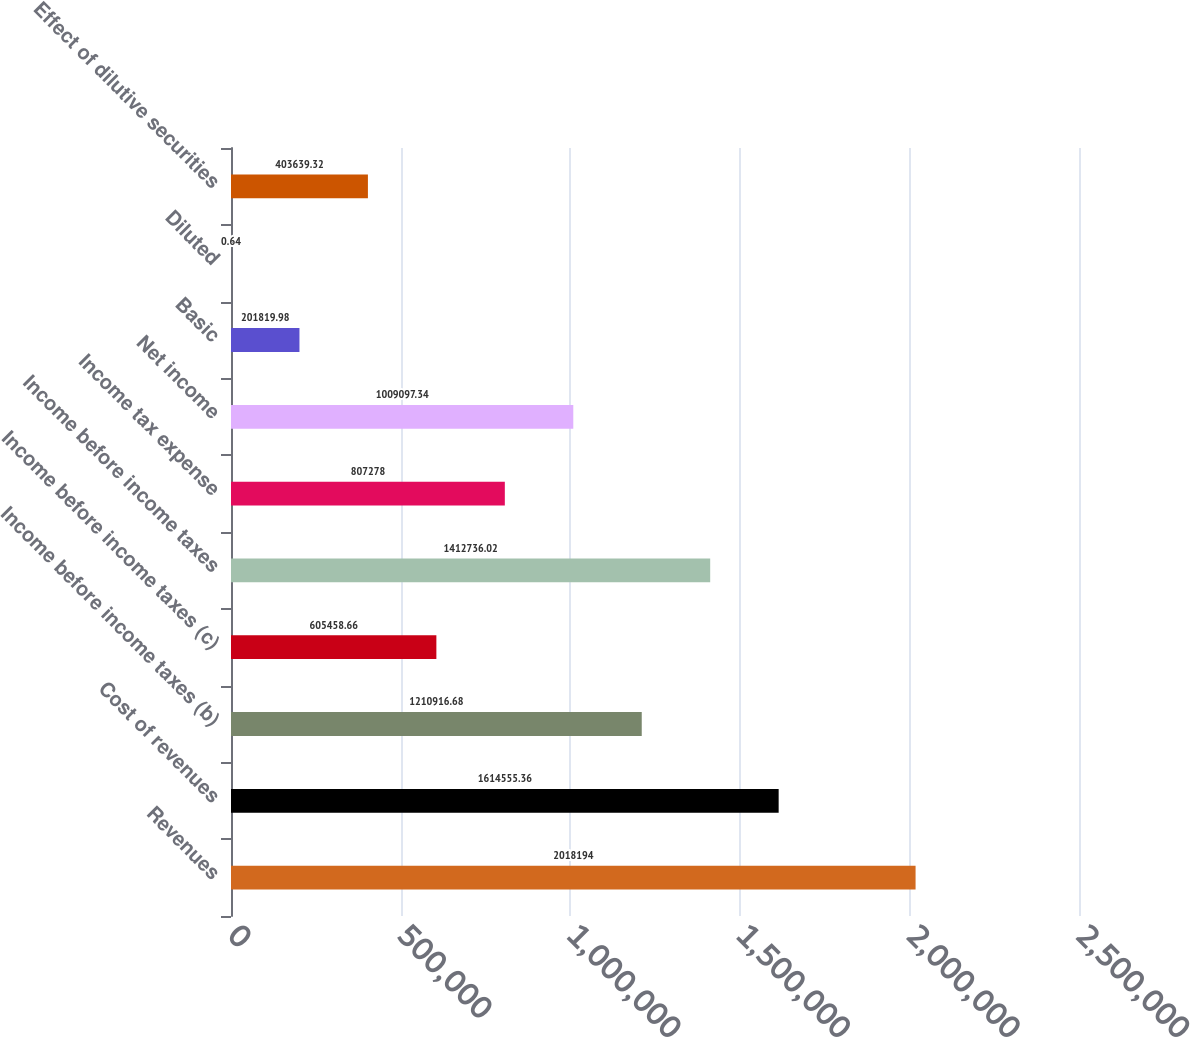Convert chart to OTSL. <chart><loc_0><loc_0><loc_500><loc_500><bar_chart><fcel>Revenues<fcel>Cost of revenues<fcel>Income before income taxes (b)<fcel>Income before income taxes (c)<fcel>Income before income taxes<fcel>Income tax expense<fcel>Net income<fcel>Basic<fcel>Diluted<fcel>Effect of dilutive securities<nl><fcel>2.01819e+06<fcel>1.61456e+06<fcel>1.21092e+06<fcel>605459<fcel>1.41274e+06<fcel>807278<fcel>1.0091e+06<fcel>201820<fcel>0.64<fcel>403639<nl></chart> 